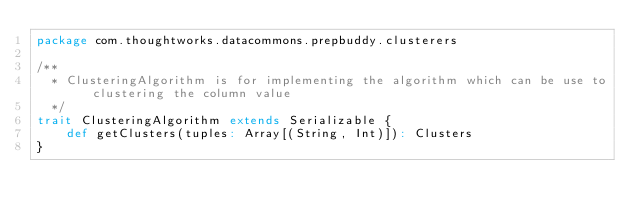Convert code to text. <code><loc_0><loc_0><loc_500><loc_500><_Scala_>package com.thoughtworks.datacommons.prepbuddy.clusterers

/**
  * ClusteringAlgorithm is for implementing the algorithm which can be use to clustering the column value
  */
trait ClusteringAlgorithm extends Serializable {
    def getClusters(tuples: Array[(String, Int)]): Clusters
}
</code> 